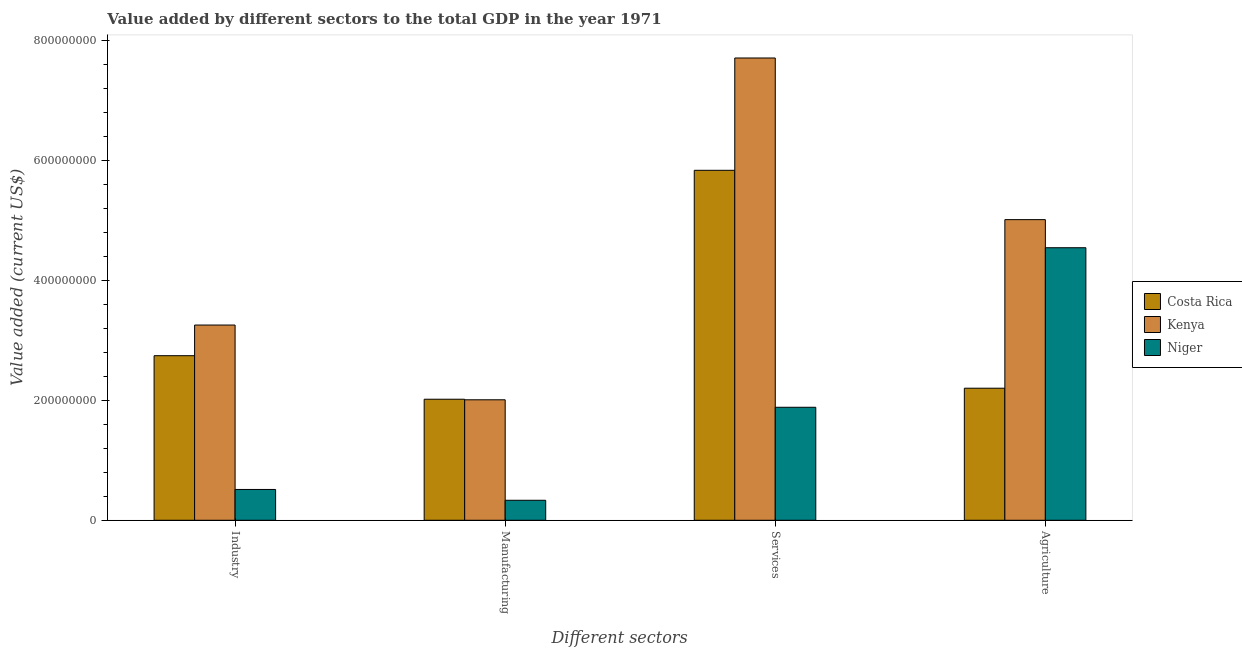How many groups of bars are there?
Offer a terse response. 4. Are the number of bars per tick equal to the number of legend labels?
Ensure brevity in your answer.  Yes. How many bars are there on the 4th tick from the left?
Keep it short and to the point. 3. What is the label of the 2nd group of bars from the left?
Keep it short and to the point. Manufacturing. What is the value added by services sector in Niger?
Offer a terse response. 1.88e+08. Across all countries, what is the maximum value added by manufacturing sector?
Keep it short and to the point. 2.02e+08. Across all countries, what is the minimum value added by industrial sector?
Make the answer very short. 5.13e+07. In which country was the value added by manufacturing sector maximum?
Give a very brief answer. Costa Rica. In which country was the value added by agricultural sector minimum?
Ensure brevity in your answer.  Costa Rica. What is the total value added by services sector in the graph?
Make the answer very short. 1.54e+09. What is the difference between the value added by services sector in Costa Rica and that in Kenya?
Your answer should be very brief. -1.87e+08. What is the difference between the value added by agricultural sector in Niger and the value added by manufacturing sector in Costa Rica?
Your answer should be compact. 2.52e+08. What is the average value added by agricultural sector per country?
Provide a short and direct response. 3.92e+08. What is the difference between the value added by services sector and value added by agricultural sector in Costa Rica?
Give a very brief answer. 3.63e+08. What is the ratio of the value added by industrial sector in Costa Rica to that in Niger?
Provide a succinct answer. 5.34. Is the value added by manufacturing sector in Kenya less than that in Costa Rica?
Your answer should be very brief. Yes. What is the difference between the highest and the second highest value added by manufacturing sector?
Offer a very short reply. 9.32e+05. What is the difference between the highest and the lowest value added by manufacturing sector?
Keep it short and to the point. 1.68e+08. Is the sum of the value added by agricultural sector in Costa Rica and Kenya greater than the maximum value added by services sector across all countries?
Provide a succinct answer. No. Is it the case that in every country, the sum of the value added by services sector and value added by manufacturing sector is greater than the sum of value added by agricultural sector and value added by industrial sector?
Your answer should be compact. No. What does the 3rd bar from the left in Agriculture represents?
Offer a terse response. Niger. What does the 1st bar from the right in Industry represents?
Your response must be concise. Niger. Is it the case that in every country, the sum of the value added by industrial sector and value added by manufacturing sector is greater than the value added by services sector?
Your answer should be compact. No. Are all the bars in the graph horizontal?
Give a very brief answer. No. How many countries are there in the graph?
Give a very brief answer. 3. What is the difference between two consecutive major ticks on the Y-axis?
Offer a very short reply. 2.00e+08. Are the values on the major ticks of Y-axis written in scientific E-notation?
Your answer should be compact. No. Does the graph contain grids?
Your answer should be very brief. No. What is the title of the graph?
Offer a terse response. Value added by different sectors to the total GDP in the year 1971. Does "Togo" appear as one of the legend labels in the graph?
Keep it short and to the point. No. What is the label or title of the X-axis?
Make the answer very short. Different sectors. What is the label or title of the Y-axis?
Provide a short and direct response. Value added (current US$). What is the Value added (current US$) in Costa Rica in Industry?
Your response must be concise. 2.74e+08. What is the Value added (current US$) of Kenya in Industry?
Offer a very short reply. 3.25e+08. What is the Value added (current US$) of Niger in Industry?
Keep it short and to the point. 5.13e+07. What is the Value added (current US$) in Costa Rica in Manufacturing?
Provide a short and direct response. 2.02e+08. What is the Value added (current US$) in Kenya in Manufacturing?
Provide a succinct answer. 2.01e+08. What is the Value added (current US$) in Niger in Manufacturing?
Provide a short and direct response. 3.33e+07. What is the Value added (current US$) in Costa Rica in Services?
Offer a terse response. 5.83e+08. What is the Value added (current US$) in Kenya in Services?
Make the answer very short. 7.70e+08. What is the Value added (current US$) in Niger in Services?
Provide a short and direct response. 1.88e+08. What is the Value added (current US$) in Costa Rica in Agriculture?
Provide a short and direct response. 2.20e+08. What is the Value added (current US$) in Kenya in Agriculture?
Ensure brevity in your answer.  5.01e+08. What is the Value added (current US$) in Niger in Agriculture?
Provide a short and direct response. 4.54e+08. Across all Different sectors, what is the maximum Value added (current US$) in Costa Rica?
Your answer should be very brief. 5.83e+08. Across all Different sectors, what is the maximum Value added (current US$) in Kenya?
Offer a very short reply. 7.70e+08. Across all Different sectors, what is the maximum Value added (current US$) in Niger?
Make the answer very short. 4.54e+08. Across all Different sectors, what is the minimum Value added (current US$) of Costa Rica?
Keep it short and to the point. 2.02e+08. Across all Different sectors, what is the minimum Value added (current US$) of Kenya?
Offer a terse response. 2.01e+08. Across all Different sectors, what is the minimum Value added (current US$) in Niger?
Your response must be concise. 3.33e+07. What is the total Value added (current US$) of Costa Rica in the graph?
Give a very brief answer. 1.28e+09. What is the total Value added (current US$) of Kenya in the graph?
Give a very brief answer. 1.80e+09. What is the total Value added (current US$) of Niger in the graph?
Ensure brevity in your answer.  7.27e+08. What is the difference between the Value added (current US$) in Costa Rica in Industry and that in Manufacturing?
Provide a short and direct response. 7.25e+07. What is the difference between the Value added (current US$) in Kenya in Industry and that in Manufacturing?
Ensure brevity in your answer.  1.25e+08. What is the difference between the Value added (current US$) of Niger in Industry and that in Manufacturing?
Give a very brief answer. 1.80e+07. What is the difference between the Value added (current US$) in Costa Rica in Industry and that in Services?
Your response must be concise. -3.09e+08. What is the difference between the Value added (current US$) of Kenya in Industry and that in Services?
Offer a terse response. -4.45e+08. What is the difference between the Value added (current US$) of Niger in Industry and that in Services?
Give a very brief answer. -1.37e+08. What is the difference between the Value added (current US$) of Costa Rica in Industry and that in Agriculture?
Ensure brevity in your answer.  5.42e+07. What is the difference between the Value added (current US$) in Kenya in Industry and that in Agriculture?
Ensure brevity in your answer.  -1.76e+08. What is the difference between the Value added (current US$) of Niger in Industry and that in Agriculture?
Give a very brief answer. -4.03e+08. What is the difference between the Value added (current US$) of Costa Rica in Manufacturing and that in Services?
Your answer should be compact. -3.81e+08. What is the difference between the Value added (current US$) of Kenya in Manufacturing and that in Services?
Your answer should be very brief. -5.69e+08. What is the difference between the Value added (current US$) of Niger in Manufacturing and that in Services?
Offer a terse response. -1.55e+08. What is the difference between the Value added (current US$) of Costa Rica in Manufacturing and that in Agriculture?
Give a very brief answer. -1.84e+07. What is the difference between the Value added (current US$) of Kenya in Manufacturing and that in Agriculture?
Provide a short and direct response. -3.00e+08. What is the difference between the Value added (current US$) of Niger in Manufacturing and that in Agriculture?
Provide a short and direct response. -4.21e+08. What is the difference between the Value added (current US$) of Costa Rica in Services and that in Agriculture?
Offer a very short reply. 3.63e+08. What is the difference between the Value added (current US$) in Kenya in Services and that in Agriculture?
Give a very brief answer. 2.69e+08. What is the difference between the Value added (current US$) of Niger in Services and that in Agriculture?
Offer a terse response. -2.66e+08. What is the difference between the Value added (current US$) of Costa Rica in Industry and the Value added (current US$) of Kenya in Manufacturing?
Offer a very short reply. 7.35e+07. What is the difference between the Value added (current US$) in Costa Rica in Industry and the Value added (current US$) in Niger in Manufacturing?
Provide a succinct answer. 2.41e+08. What is the difference between the Value added (current US$) of Kenya in Industry and the Value added (current US$) of Niger in Manufacturing?
Your response must be concise. 2.92e+08. What is the difference between the Value added (current US$) in Costa Rica in Industry and the Value added (current US$) in Kenya in Services?
Provide a short and direct response. -4.96e+08. What is the difference between the Value added (current US$) in Costa Rica in Industry and the Value added (current US$) in Niger in Services?
Your answer should be compact. 8.59e+07. What is the difference between the Value added (current US$) of Kenya in Industry and the Value added (current US$) of Niger in Services?
Keep it short and to the point. 1.37e+08. What is the difference between the Value added (current US$) in Costa Rica in Industry and the Value added (current US$) in Kenya in Agriculture?
Provide a short and direct response. -2.27e+08. What is the difference between the Value added (current US$) in Costa Rica in Industry and the Value added (current US$) in Niger in Agriculture?
Make the answer very short. -1.80e+08. What is the difference between the Value added (current US$) of Kenya in Industry and the Value added (current US$) of Niger in Agriculture?
Give a very brief answer. -1.29e+08. What is the difference between the Value added (current US$) in Costa Rica in Manufacturing and the Value added (current US$) in Kenya in Services?
Keep it short and to the point. -5.68e+08. What is the difference between the Value added (current US$) of Costa Rica in Manufacturing and the Value added (current US$) of Niger in Services?
Offer a very short reply. 1.34e+07. What is the difference between the Value added (current US$) in Kenya in Manufacturing and the Value added (current US$) in Niger in Services?
Provide a succinct answer. 1.25e+07. What is the difference between the Value added (current US$) in Costa Rica in Manufacturing and the Value added (current US$) in Kenya in Agriculture?
Your answer should be compact. -2.99e+08. What is the difference between the Value added (current US$) of Costa Rica in Manufacturing and the Value added (current US$) of Niger in Agriculture?
Give a very brief answer. -2.52e+08. What is the difference between the Value added (current US$) in Kenya in Manufacturing and the Value added (current US$) in Niger in Agriculture?
Your answer should be very brief. -2.53e+08. What is the difference between the Value added (current US$) in Costa Rica in Services and the Value added (current US$) in Kenya in Agriculture?
Your response must be concise. 8.22e+07. What is the difference between the Value added (current US$) of Costa Rica in Services and the Value added (current US$) of Niger in Agriculture?
Keep it short and to the point. 1.29e+08. What is the difference between the Value added (current US$) of Kenya in Services and the Value added (current US$) of Niger in Agriculture?
Provide a succinct answer. 3.16e+08. What is the average Value added (current US$) in Costa Rica per Different sectors?
Give a very brief answer. 3.20e+08. What is the average Value added (current US$) of Kenya per Different sectors?
Ensure brevity in your answer.  4.49e+08. What is the average Value added (current US$) of Niger per Different sectors?
Make the answer very short. 1.82e+08. What is the difference between the Value added (current US$) of Costa Rica and Value added (current US$) of Kenya in Industry?
Make the answer very short. -5.11e+07. What is the difference between the Value added (current US$) in Costa Rica and Value added (current US$) in Niger in Industry?
Provide a succinct answer. 2.23e+08. What is the difference between the Value added (current US$) of Kenya and Value added (current US$) of Niger in Industry?
Offer a terse response. 2.74e+08. What is the difference between the Value added (current US$) in Costa Rica and Value added (current US$) in Kenya in Manufacturing?
Provide a short and direct response. 9.32e+05. What is the difference between the Value added (current US$) in Costa Rica and Value added (current US$) in Niger in Manufacturing?
Offer a terse response. 1.68e+08. What is the difference between the Value added (current US$) of Kenya and Value added (current US$) of Niger in Manufacturing?
Offer a terse response. 1.67e+08. What is the difference between the Value added (current US$) in Costa Rica and Value added (current US$) in Kenya in Services?
Offer a terse response. -1.87e+08. What is the difference between the Value added (current US$) of Costa Rica and Value added (current US$) of Niger in Services?
Offer a very short reply. 3.95e+08. What is the difference between the Value added (current US$) of Kenya and Value added (current US$) of Niger in Services?
Ensure brevity in your answer.  5.82e+08. What is the difference between the Value added (current US$) of Costa Rica and Value added (current US$) of Kenya in Agriculture?
Give a very brief answer. -2.81e+08. What is the difference between the Value added (current US$) in Costa Rica and Value added (current US$) in Niger in Agriculture?
Offer a terse response. -2.34e+08. What is the difference between the Value added (current US$) of Kenya and Value added (current US$) of Niger in Agriculture?
Provide a short and direct response. 4.68e+07. What is the ratio of the Value added (current US$) in Costa Rica in Industry to that in Manufacturing?
Your response must be concise. 1.36. What is the ratio of the Value added (current US$) of Kenya in Industry to that in Manufacturing?
Offer a terse response. 1.62. What is the ratio of the Value added (current US$) in Niger in Industry to that in Manufacturing?
Make the answer very short. 1.54. What is the ratio of the Value added (current US$) in Costa Rica in Industry to that in Services?
Your answer should be compact. 0.47. What is the ratio of the Value added (current US$) of Kenya in Industry to that in Services?
Your answer should be compact. 0.42. What is the ratio of the Value added (current US$) of Niger in Industry to that in Services?
Your answer should be very brief. 0.27. What is the ratio of the Value added (current US$) of Costa Rica in Industry to that in Agriculture?
Ensure brevity in your answer.  1.25. What is the ratio of the Value added (current US$) of Kenya in Industry to that in Agriculture?
Offer a very short reply. 0.65. What is the ratio of the Value added (current US$) in Niger in Industry to that in Agriculture?
Give a very brief answer. 0.11. What is the ratio of the Value added (current US$) of Costa Rica in Manufacturing to that in Services?
Your answer should be very brief. 0.35. What is the ratio of the Value added (current US$) in Kenya in Manufacturing to that in Services?
Provide a short and direct response. 0.26. What is the ratio of the Value added (current US$) in Niger in Manufacturing to that in Services?
Your answer should be very brief. 0.18. What is the ratio of the Value added (current US$) in Costa Rica in Manufacturing to that in Agriculture?
Give a very brief answer. 0.92. What is the ratio of the Value added (current US$) in Kenya in Manufacturing to that in Agriculture?
Give a very brief answer. 0.4. What is the ratio of the Value added (current US$) in Niger in Manufacturing to that in Agriculture?
Make the answer very short. 0.07. What is the ratio of the Value added (current US$) of Costa Rica in Services to that in Agriculture?
Offer a very short reply. 2.65. What is the ratio of the Value added (current US$) of Kenya in Services to that in Agriculture?
Provide a succinct answer. 1.54. What is the ratio of the Value added (current US$) of Niger in Services to that in Agriculture?
Your response must be concise. 0.41. What is the difference between the highest and the second highest Value added (current US$) of Costa Rica?
Your answer should be compact. 3.09e+08. What is the difference between the highest and the second highest Value added (current US$) of Kenya?
Your answer should be compact. 2.69e+08. What is the difference between the highest and the second highest Value added (current US$) of Niger?
Make the answer very short. 2.66e+08. What is the difference between the highest and the lowest Value added (current US$) of Costa Rica?
Provide a short and direct response. 3.81e+08. What is the difference between the highest and the lowest Value added (current US$) in Kenya?
Your answer should be compact. 5.69e+08. What is the difference between the highest and the lowest Value added (current US$) in Niger?
Your response must be concise. 4.21e+08. 